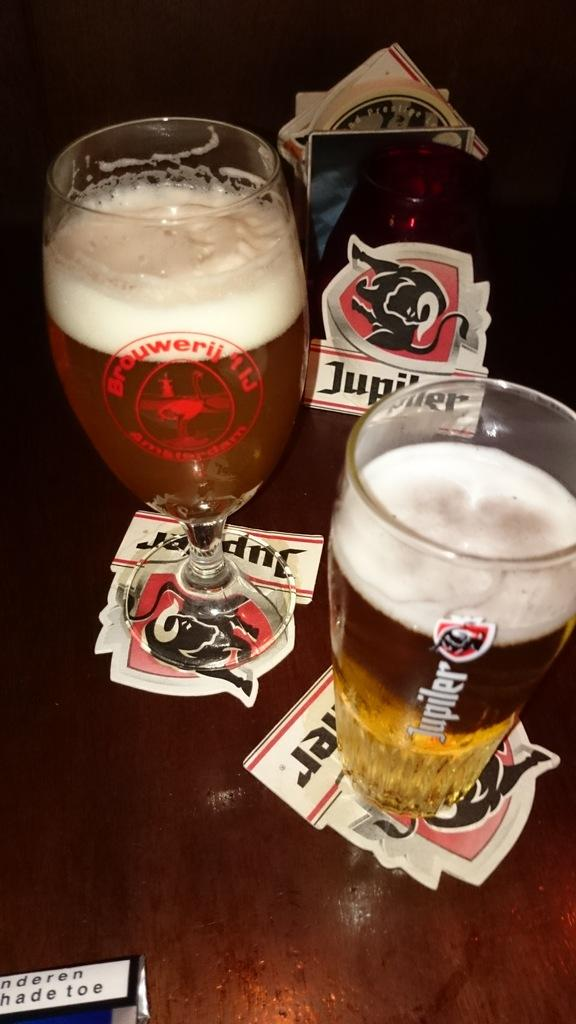<image>
Create a compact narrative representing the image presented. A mug of beer in a Jupiter glass sits on a Jupiter napkin next to a taller glass of beer. 